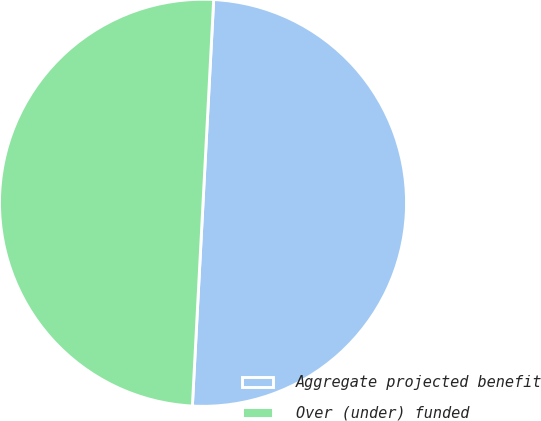Convert chart to OTSL. <chart><loc_0><loc_0><loc_500><loc_500><pie_chart><fcel>Aggregate projected benefit<fcel>Over (under) funded<nl><fcel>50.0%<fcel>50.0%<nl></chart> 